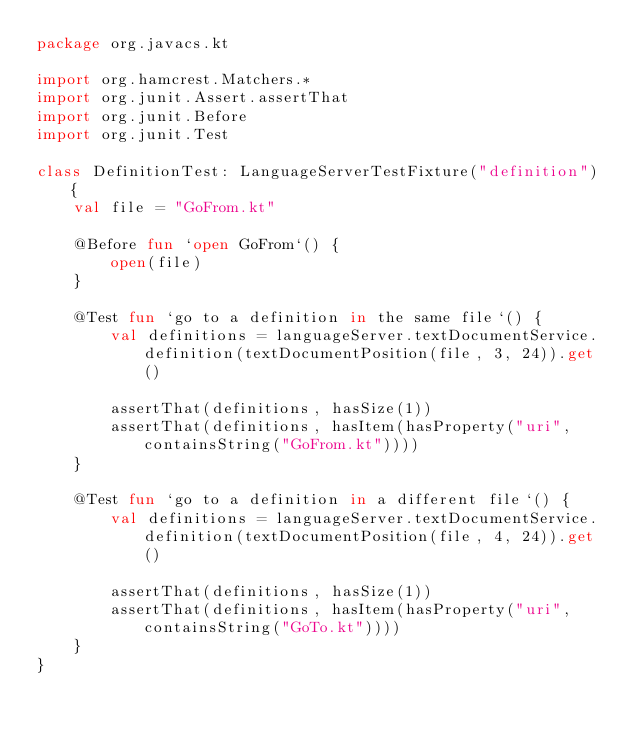Convert code to text. <code><loc_0><loc_0><loc_500><loc_500><_Kotlin_>package org.javacs.kt

import org.hamcrest.Matchers.*
import org.junit.Assert.assertThat
import org.junit.Before
import org.junit.Test

class DefinitionTest: LanguageServerTestFixture("definition") {
    val file = "GoFrom.kt"

    @Before fun `open GoFrom`() {
        open(file)
    }

    @Test fun `go to a definition in the same file`() {
        val definitions = languageServer.textDocumentService.definition(textDocumentPosition(file, 3, 24)).get()

        assertThat(definitions, hasSize(1))
        assertThat(definitions, hasItem(hasProperty("uri", containsString("GoFrom.kt"))))
    }

    @Test fun `go to a definition in a different file`() {
        val definitions = languageServer.textDocumentService.definition(textDocumentPosition(file, 4, 24)).get()

        assertThat(definitions, hasSize(1))
        assertThat(definitions, hasItem(hasProperty("uri", containsString("GoTo.kt"))))
    }
}</code> 